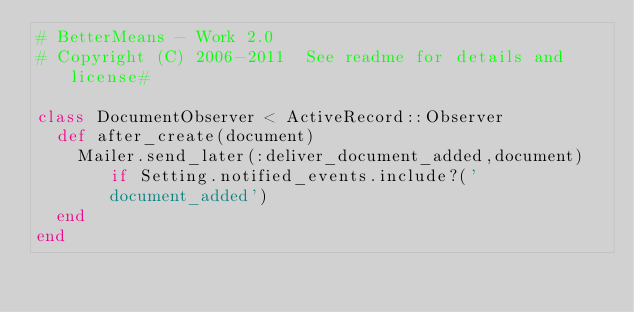<code> <loc_0><loc_0><loc_500><loc_500><_Ruby_># BetterMeans - Work 2.0
# Copyright (C) 2006-2011  See readme for details and license#

class DocumentObserver < ActiveRecord::Observer
  def after_create(document)
    Mailer.send_later(:deliver_document_added,document) if Setting.notified_events.include?('document_added')
  end
end
</code> 